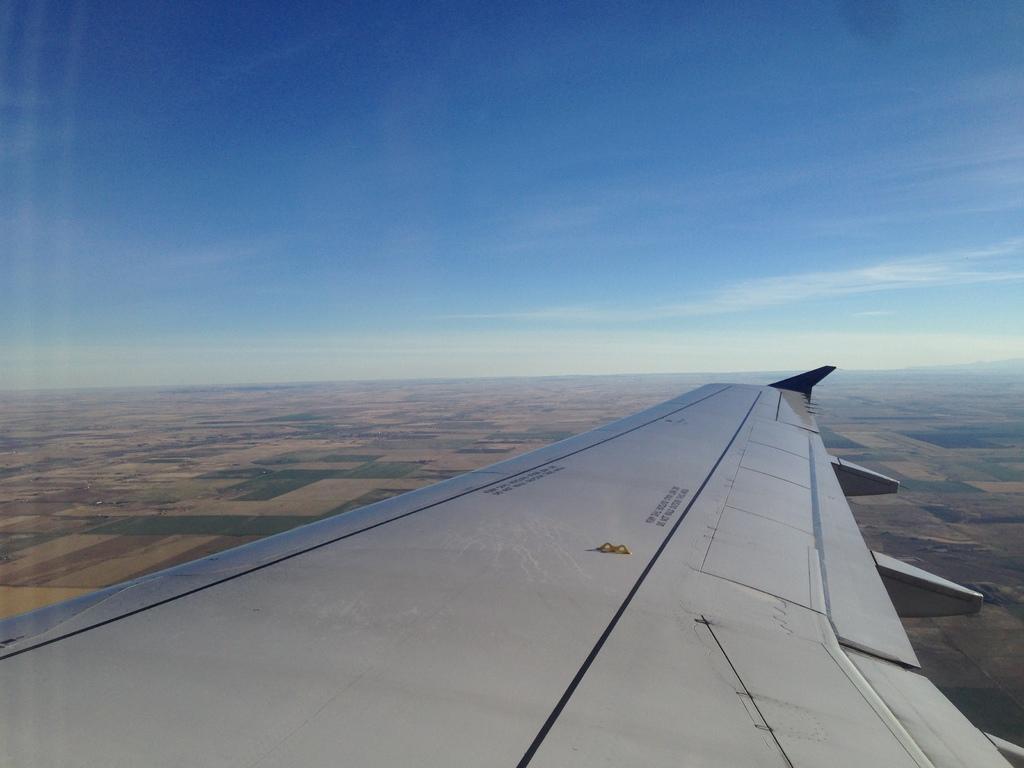How would you summarize this image in a sentence or two? In this picture there is an airplane. At the top there is sky and there are clouds. At the bottom there is grass and there are fields. 